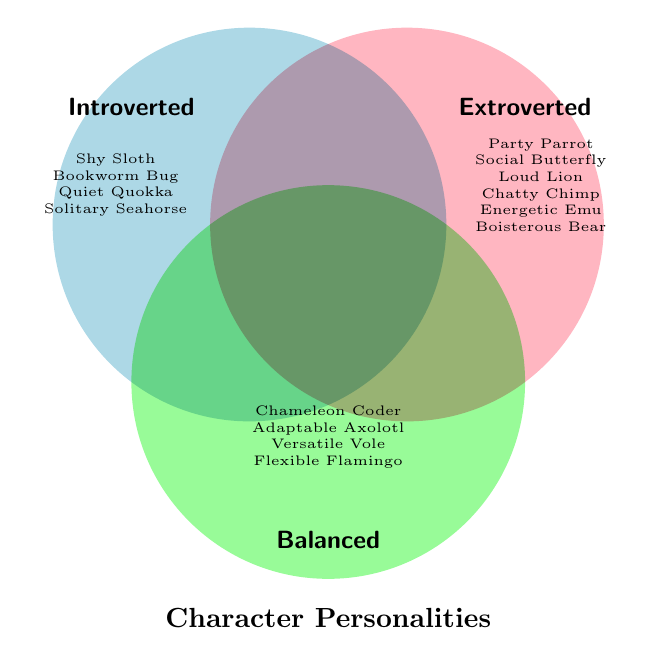What's the title of the figure? The title can be identified by looking at the top-center or bottom-center of the diagram, where it's usually placed for easy visibility.
Answer: Character Personalities How many characters are labeled as Introverted? Look at the section of the diagram labeled "Introverted" and count the characters listed there.
Answer: 4 Which character is listed under both Extroverted and Balanced? Check the overlapping area of the circles for Extroverted and Balanced to see if any name appears in both categories.
Answer: None How many characters are classified as Extroverted? Refer to the section of the diagram labeled "Extroverted" and count the characters listed there.
Answer: 6 Are there more characters labeled as Balanced or Introverted? Compare the number of characters in the "Balanced" section with those in the "Introverted" section.
Answer: Balanced How many characters are not labeled under any personality type? Look for any section outside the three labeled categories and see if there are any characters listed there.
Answer: 0 Which personality type has the most characters? Compare the counts of characters in the Introverted, Extroverted, and Balanced sections to determine the one with the highest count.
Answer: Extroverted Is "Chatty Chimp" labeled as Introverted? Check the "Introverted" section of the diagram to see if "Chatty Chimp" is listed there.
Answer: No Which personality type includes "Flexible Flamingo"? Look for "Flexible Flamingo" in the diagram and see which category it belongs to.
Answer: Balanced How many characters are listed under both Extroverted and Introverted? Check the overlapping section of the Extroverted and Introverted circles to see if any names appear in both categories.
Answer: 0 